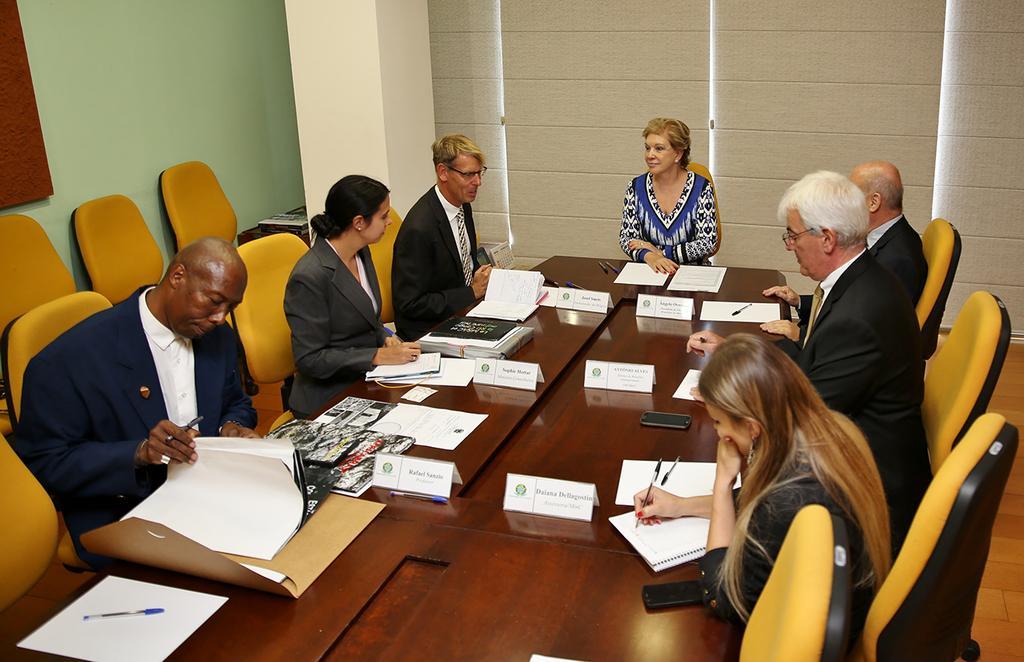How would you summarize this image in a sentence or two? In this picture we can see a group of people sitting on chair i think it is meeting and in front of them we have table and on table we can see mobile, book, paper, name boards and in background we can see wall, pillar and some more chairs. 